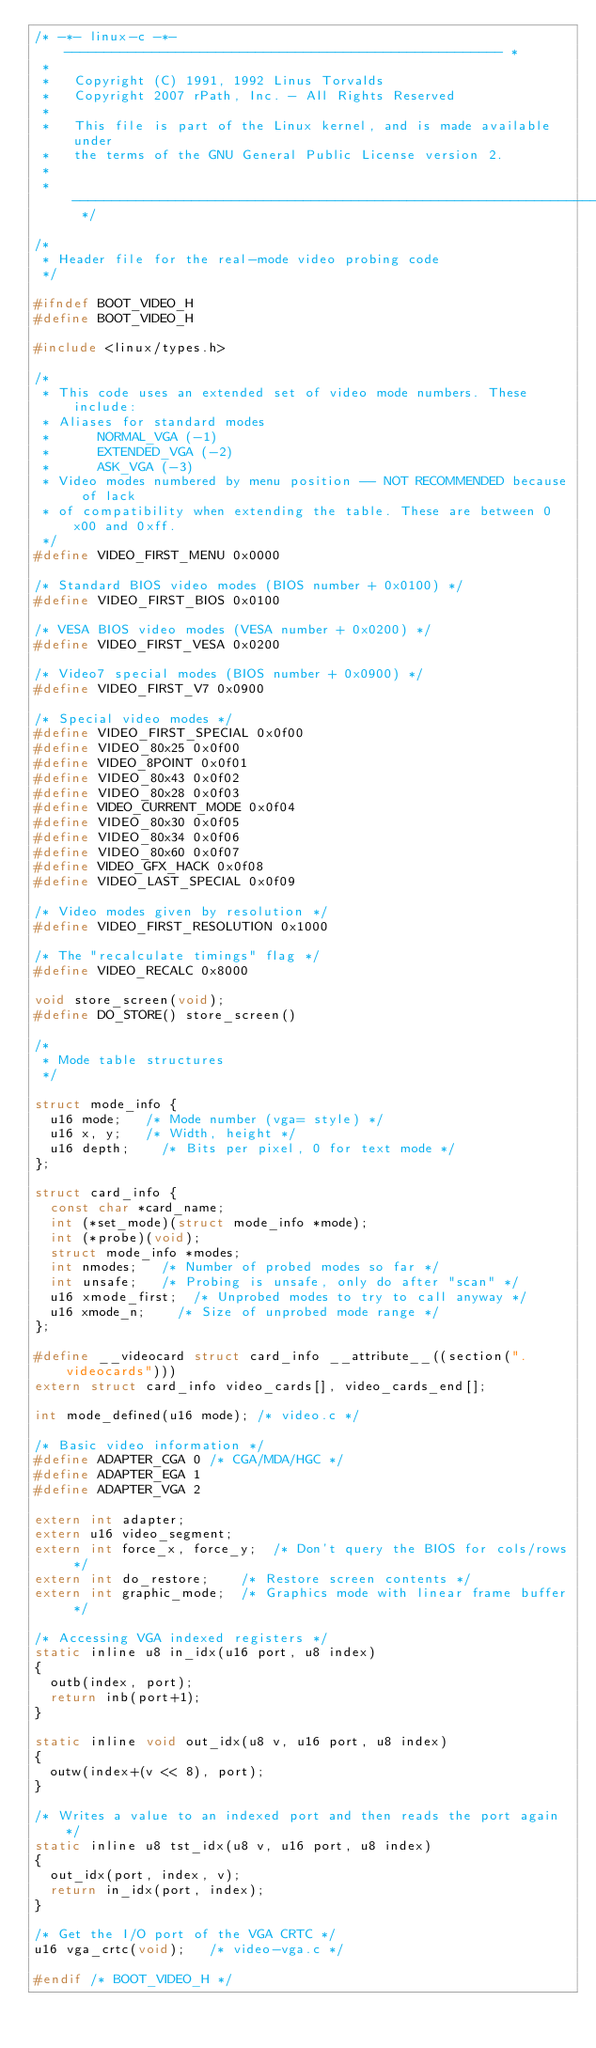<code> <loc_0><loc_0><loc_500><loc_500><_C_>/* -*- linux-c -*- ------------------------------------------------------- *
 *
 *   Copyright (C) 1991, 1992 Linus Torvalds
 *   Copyright 2007 rPath, Inc. - All Rights Reserved
 *
 *   This file is part of the Linux kernel, and is made available under
 *   the terms of the GNU General Public License version 2.
 *
 * ----------------------------------------------------------------------- */

/*
 * Header file for the real-mode video probing code
 */

#ifndef BOOT_VIDEO_H
#define BOOT_VIDEO_H

#include <linux/types.h>

/*
 * This code uses an extended set of video mode numbers. These include:
 * Aliases for standard modes
 *      NORMAL_VGA (-1)
 *      EXTENDED_VGA (-2)
 *      ASK_VGA (-3)
 * Video modes numbered by menu position -- NOT RECOMMENDED because of lack
 * of compatibility when extending the table. These are between 0x00 and 0xff.
 */
#define VIDEO_FIRST_MENU 0x0000

/* Standard BIOS video modes (BIOS number + 0x0100) */
#define VIDEO_FIRST_BIOS 0x0100

/* VESA BIOS video modes (VESA number + 0x0200) */
#define VIDEO_FIRST_VESA 0x0200

/* Video7 special modes (BIOS number + 0x0900) */
#define VIDEO_FIRST_V7 0x0900

/* Special video modes */
#define VIDEO_FIRST_SPECIAL 0x0f00
#define VIDEO_80x25 0x0f00
#define VIDEO_8POINT 0x0f01
#define VIDEO_80x43 0x0f02
#define VIDEO_80x28 0x0f03
#define VIDEO_CURRENT_MODE 0x0f04
#define VIDEO_80x30 0x0f05
#define VIDEO_80x34 0x0f06
#define VIDEO_80x60 0x0f07
#define VIDEO_GFX_HACK 0x0f08
#define VIDEO_LAST_SPECIAL 0x0f09

/* Video modes given by resolution */
#define VIDEO_FIRST_RESOLUTION 0x1000

/* The "recalculate timings" flag */
#define VIDEO_RECALC 0x8000

void store_screen(void);
#define DO_STORE() store_screen()

/*
 * Mode table structures
 */

struct mode_info {
	u16 mode;		/* Mode number (vga= style) */
	u16 x, y;		/* Width, height */
	u16 depth;		/* Bits per pixel, 0 for text mode */
};

struct card_info {
	const char *card_name;
	int (*set_mode)(struct mode_info *mode);
	int (*probe)(void);
	struct mode_info *modes;
	int nmodes;		/* Number of probed modes so far */
	int unsafe;		/* Probing is unsafe, only do after "scan" */
	u16 xmode_first;	/* Unprobed modes to try to call anyway */
	u16 xmode_n;		/* Size of unprobed mode range */
};

#define __videocard struct card_info __attribute__((section(".videocards")))
extern struct card_info video_cards[], video_cards_end[];

int mode_defined(u16 mode);	/* video.c */

/* Basic video information */
#define ADAPTER_CGA	0	/* CGA/MDA/HGC */
#define ADAPTER_EGA	1
#define ADAPTER_VGA	2

extern int adapter;
extern u16 video_segment;
extern int force_x, force_y;	/* Don't query the BIOS for cols/rows */
extern int do_restore;		/* Restore screen contents */
extern int graphic_mode;	/* Graphics mode with linear frame buffer */

/* Accessing VGA indexed registers */
static inline u8 in_idx(u16 port, u8 index)
{
	outb(index, port);
	return inb(port+1);
}

static inline void out_idx(u8 v, u16 port, u8 index)
{
	outw(index+(v << 8), port);
}

/* Writes a value to an indexed port and then reads the port again */
static inline u8 tst_idx(u8 v, u16 port, u8 index)
{
	out_idx(port, index, v);
	return in_idx(port, index);
}

/* Get the I/O port of the VGA CRTC */
u16 vga_crtc(void);		/* video-vga.c */

#endif /* BOOT_VIDEO_H */
</code> 